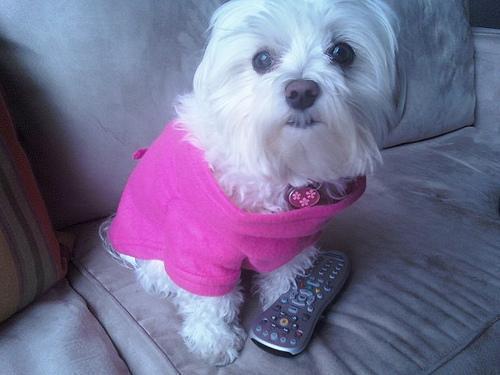How many dogs are pictured?
Give a very brief answer. 1. 